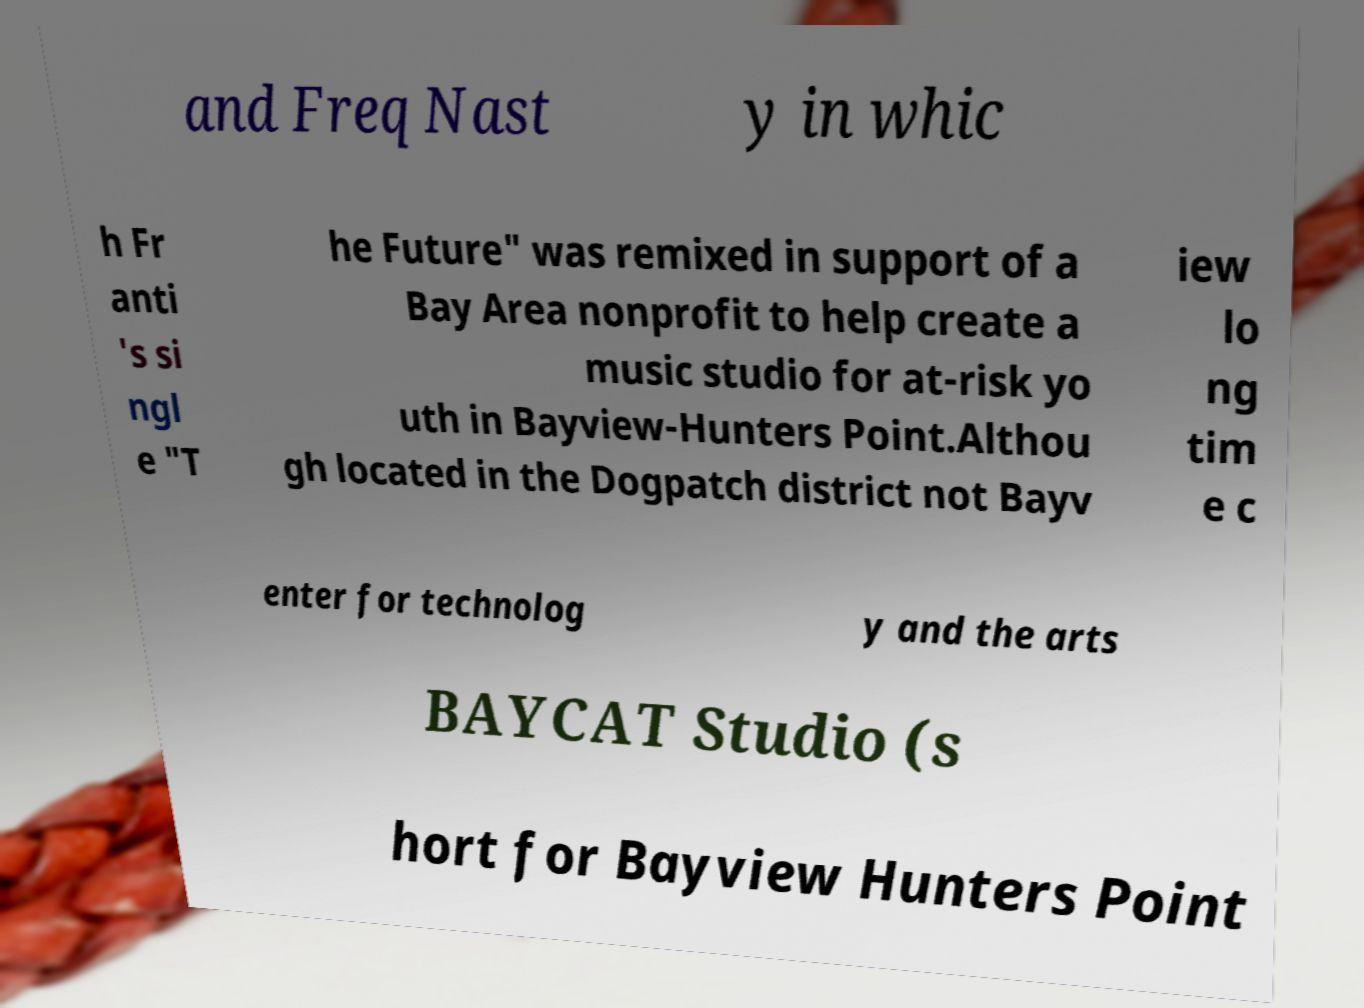There's text embedded in this image that I need extracted. Can you transcribe it verbatim? and Freq Nast y in whic h Fr anti 's si ngl e "T he Future" was remixed in support of a Bay Area nonprofit to help create a music studio for at-risk yo uth in Bayview-Hunters Point.Althou gh located in the Dogpatch district not Bayv iew lo ng tim e c enter for technolog y and the arts BAYCAT Studio (s hort for Bayview Hunters Point 